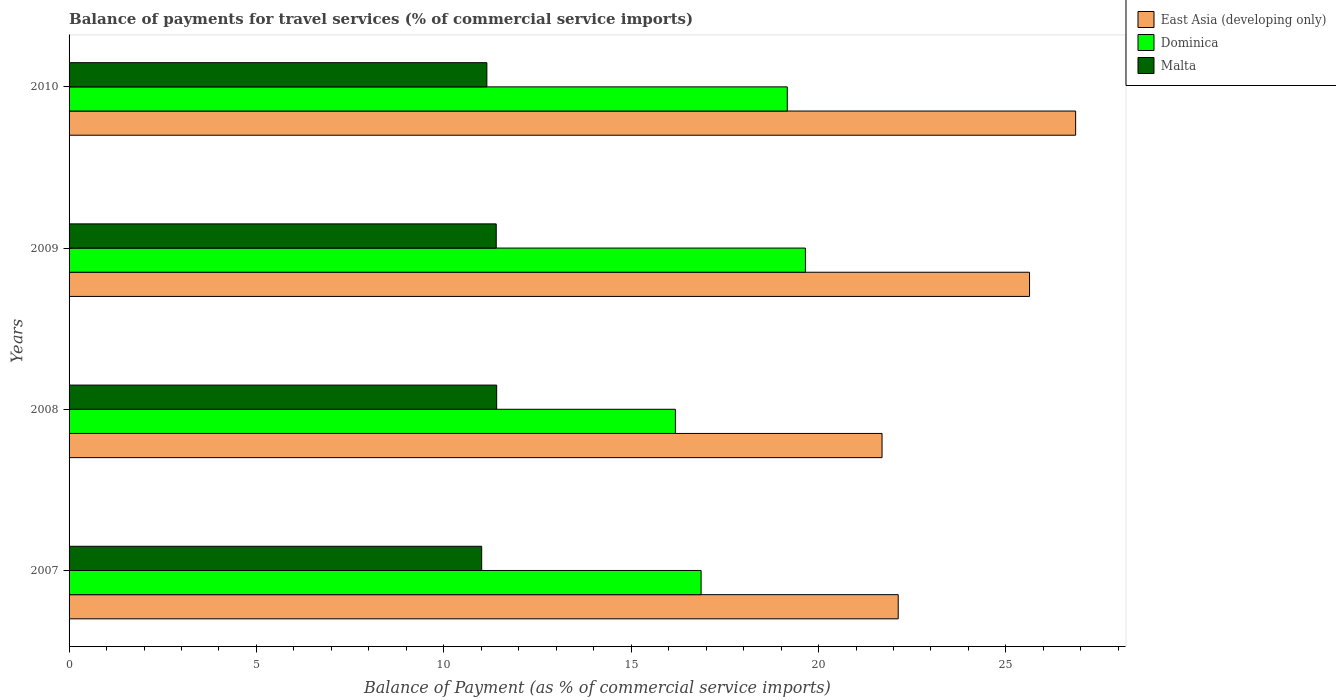How many different coloured bars are there?
Your answer should be very brief. 3. How many groups of bars are there?
Offer a very short reply. 4. Are the number of bars per tick equal to the number of legend labels?
Your answer should be very brief. Yes. Are the number of bars on each tick of the Y-axis equal?
Ensure brevity in your answer.  Yes. What is the balance of payments for travel services in Dominica in 2008?
Make the answer very short. 16.18. Across all years, what is the maximum balance of payments for travel services in Malta?
Your response must be concise. 11.41. Across all years, what is the minimum balance of payments for travel services in Dominica?
Your answer should be compact. 16.18. What is the total balance of payments for travel services in Dominica in the graph?
Provide a succinct answer. 71.86. What is the difference between the balance of payments for travel services in East Asia (developing only) in 2007 and that in 2010?
Provide a succinct answer. -4.73. What is the difference between the balance of payments for travel services in Malta in 2009 and the balance of payments for travel services in East Asia (developing only) in 2008?
Your answer should be compact. -10.3. What is the average balance of payments for travel services in Malta per year?
Your response must be concise. 11.24. In the year 2008, what is the difference between the balance of payments for travel services in East Asia (developing only) and balance of payments for travel services in Malta?
Your answer should be very brief. 10.28. What is the ratio of the balance of payments for travel services in Dominica in 2007 to that in 2010?
Offer a very short reply. 0.88. Is the difference between the balance of payments for travel services in East Asia (developing only) in 2007 and 2008 greater than the difference between the balance of payments for travel services in Malta in 2007 and 2008?
Offer a very short reply. Yes. What is the difference between the highest and the second highest balance of payments for travel services in Dominica?
Provide a short and direct response. 0.48. What is the difference between the highest and the lowest balance of payments for travel services in Malta?
Provide a succinct answer. 0.4. Is the sum of the balance of payments for travel services in Malta in 2007 and 2009 greater than the maximum balance of payments for travel services in Dominica across all years?
Make the answer very short. Yes. What does the 1st bar from the top in 2008 represents?
Your answer should be compact. Malta. What does the 2nd bar from the bottom in 2010 represents?
Provide a short and direct response. Dominica. Is it the case that in every year, the sum of the balance of payments for travel services in East Asia (developing only) and balance of payments for travel services in Malta is greater than the balance of payments for travel services in Dominica?
Keep it short and to the point. Yes. How many bars are there?
Make the answer very short. 12. How many years are there in the graph?
Provide a succinct answer. 4. Are the values on the major ticks of X-axis written in scientific E-notation?
Your response must be concise. No. Does the graph contain any zero values?
Offer a very short reply. No. Does the graph contain grids?
Your answer should be very brief. No. What is the title of the graph?
Keep it short and to the point. Balance of payments for travel services (% of commercial service imports). What is the label or title of the X-axis?
Your answer should be very brief. Balance of Payment (as % of commercial service imports). What is the Balance of Payment (as % of commercial service imports) in East Asia (developing only) in 2007?
Ensure brevity in your answer.  22.13. What is the Balance of Payment (as % of commercial service imports) of Dominica in 2007?
Your response must be concise. 16.87. What is the Balance of Payment (as % of commercial service imports) of Malta in 2007?
Your response must be concise. 11.01. What is the Balance of Payment (as % of commercial service imports) of East Asia (developing only) in 2008?
Keep it short and to the point. 21.69. What is the Balance of Payment (as % of commercial service imports) of Dominica in 2008?
Give a very brief answer. 16.18. What is the Balance of Payment (as % of commercial service imports) of Malta in 2008?
Give a very brief answer. 11.41. What is the Balance of Payment (as % of commercial service imports) in East Asia (developing only) in 2009?
Your response must be concise. 25.63. What is the Balance of Payment (as % of commercial service imports) in Dominica in 2009?
Keep it short and to the point. 19.65. What is the Balance of Payment (as % of commercial service imports) of Malta in 2009?
Give a very brief answer. 11.4. What is the Balance of Payment (as % of commercial service imports) of East Asia (developing only) in 2010?
Keep it short and to the point. 26.86. What is the Balance of Payment (as % of commercial service imports) of Dominica in 2010?
Ensure brevity in your answer.  19.17. What is the Balance of Payment (as % of commercial service imports) of Malta in 2010?
Provide a succinct answer. 11.15. Across all years, what is the maximum Balance of Payment (as % of commercial service imports) in East Asia (developing only)?
Your response must be concise. 26.86. Across all years, what is the maximum Balance of Payment (as % of commercial service imports) in Dominica?
Keep it short and to the point. 19.65. Across all years, what is the maximum Balance of Payment (as % of commercial service imports) of Malta?
Give a very brief answer. 11.41. Across all years, what is the minimum Balance of Payment (as % of commercial service imports) in East Asia (developing only)?
Provide a succinct answer. 21.69. Across all years, what is the minimum Balance of Payment (as % of commercial service imports) of Dominica?
Keep it short and to the point. 16.18. Across all years, what is the minimum Balance of Payment (as % of commercial service imports) of Malta?
Your response must be concise. 11.01. What is the total Balance of Payment (as % of commercial service imports) of East Asia (developing only) in the graph?
Your answer should be compact. 96.31. What is the total Balance of Payment (as % of commercial service imports) of Dominica in the graph?
Provide a succinct answer. 71.86. What is the total Balance of Payment (as % of commercial service imports) in Malta in the graph?
Your response must be concise. 44.97. What is the difference between the Balance of Payment (as % of commercial service imports) of East Asia (developing only) in 2007 and that in 2008?
Provide a succinct answer. 0.43. What is the difference between the Balance of Payment (as % of commercial service imports) of Dominica in 2007 and that in 2008?
Your response must be concise. 0.69. What is the difference between the Balance of Payment (as % of commercial service imports) of Malta in 2007 and that in 2008?
Your response must be concise. -0.4. What is the difference between the Balance of Payment (as % of commercial service imports) in East Asia (developing only) in 2007 and that in 2009?
Give a very brief answer. -3.5. What is the difference between the Balance of Payment (as % of commercial service imports) in Dominica in 2007 and that in 2009?
Make the answer very short. -2.78. What is the difference between the Balance of Payment (as % of commercial service imports) in Malta in 2007 and that in 2009?
Ensure brevity in your answer.  -0.39. What is the difference between the Balance of Payment (as % of commercial service imports) in East Asia (developing only) in 2007 and that in 2010?
Give a very brief answer. -4.73. What is the difference between the Balance of Payment (as % of commercial service imports) in Dominica in 2007 and that in 2010?
Keep it short and to the point. -2.3. What is the difference between the Balance of Payment (as % of commercial service imports) in Malta in 2007 and that in 2010?
Your answer should be very brief. -0.14. What is the difference between the Balance of Payment (as % of commercial service imports) of East Asia (developing only) in 2008 and that in 2009?
Your response must be concise. -3.94. What is the difference between the Balance of Payment (as % of commercial service imports) of Dominica in 2008 and that in 2009?
Offer a terse response. -3.47. What is the difference between the Balance of Payment (as % of commercial service imports) of Malta in 2008 and that in 2009?
Provide a short and direct response. 0.01. What is the difference between the Balance of Payment (as % of commercial service imports) in East Asia (developing only) in 2008 and that in 2010?
Make the answer very short. -5.17. What is the difference between the Balance of Payment (as % of commercial service imports) in Dominica in 2008 and that in 2010?
Your answer should be very brief. -2.99. What is the difference between the Balance of Payment (as % of commercial service imports) in Malta in 2008 and that in 2010?
Ensure brevity in your answer.  0.26. What is the difference between the Balance of Payment (as % of commercial service imports) of East Asia (developing only) in 2009 and that in 2010?
Your answer should be compact. -1.23. What is the difference between the Balance of Payment (as % of commercial service imports) of Dominica in 2009 and that in 2010?
Keep it short and to the point. 0.48. What is the difference between the Balance of Payment (as % of commercial service imports) of Malta in 2009 and that in 2010?
Offer a terse response. 0.25. What is the difference between the Balance of Payment (as % of commercial service imports) of East Asia (developing only) in 2007 and the Balance of Payment (as % of commercial service imports) of Dominica in 2008?
Provide a short and direct response. 5.95. What is the difference between the Balance of Payment (as % of commercial service imports) of East Asia (developing only) in 2007 and the Balance of Payment (as % of commercial service imports) of Malta in 2008?
Ensure brevity in your answer.  10.71. What is the difference between the Balance of Payment (as % of commercial service imports) in Dominica in 2007 and the Balance of Payment (as % of commercial service imports) in Malta in 2008?
Provide a short and direct response. 5.46. What is the difference between the Balance of Payment (as % of commercial service imports) of East Asia (developing only) in 2007 and the Balance of Payment (as % of commercial service imports) of Dominica in 2009?
Provide a succinct answer. 2.48. What is the difference between the Balance of Payment (as % of commercial service imports) in East Asia (developing only) in 2007 and the Balance of Payment (as % of commercial service imports) in Malta in 2009?
Your answer should be very brief. 10.73. What is the difference between the Balance of Payment (as % of commercial service imports) in Dominica in 2007 and the Balance of Payment (as % of commercial service imports) in Malta in 2009?
Your answer should be very brief. 5.47. What is the difference between the Balance of Payment (as % of commercial service imports) of East Asia (developing only) in 2007 and the Balance of Payment (as % of commercial service imports) of Dominica in 2010?
Make the answer very short. 2.96. What is the difference between the Balance of Payment (as % of commercial service imports) of East Asia (developing only) in 2007 and the Balance of Payment (as % of commercial service imports) of Malta in 2010?
Provide a succinct answer. 10.98. What is the difference between the Balance of Payment (as % of commercial service imports) in Dominica in 2007 and the Balance of Payment (as % of commercial service imports) in Malta in 2010?
Provide a succinct answer. 5.72. What is the difference between the Balance of Payment (as % of commercial service imports) in East Asia (developing only) in 2008 and the Balance of Payment (as % of commercial service imports) in Dominica in 2009?
Your response must be concise. 2.04. What is the difference between the Balance of Payment (as % of commercial service imports) of East Asia (developing only) in 2008 and the Balance of Payment (as % of commercial service imports) of Malta in 2009?
Offer a terse response. 10.3. What is the difference between the Balance of Payment (as % of commercial service imports) of Dominica in 2008 and the Balance of Payment (as % of commercial service imports) of Malta in 2009?
Your response must be concise. 4.78. What is the difference between the Balance of Payment (as % of commercial service imports) in East Asia (developing only) in 2008 and the Balance of Payment (as % of commercial service imports) in Dominica in 2010?
Make the answer very short. 2.53. What is the difference between the Balance of Payment (as % of commercial service imports) in East Asia (developing only) in 2008 and the Balance of Payment (as % of commercial service imports) in Malta in 2010?
Your answer should be very brief. 10.55. What is the difference between the Balance of Payment (as % of commercial service imports) of Dominica in 2008 and the Balance of Payment (as % of commercial service imports) of Malta in 2010?
Provide a short and direct response. 5.03. What is the difference between the Balance of Payment (as % of commercial service imports) in East Asia (developing only) in 2009 and the Balance of Payment (as % of commercial service imports) in Dominica in 2010?
Make the answer very short. 6.46. What is the difference between the Balance of Payment (as % of commercial service imports) of East Asia (developing only) in 2009 and the Balance of Payment (as % of commercial service imports) of Malta in 2010?
Your answer should be compact. 14.48. What is the difference between the Balance of Payment (as % of commercial service imports) in Dominica in 2009 and the Balance of Payment (as % of commercial service imports) in Malta in 2010?
Provide a succinct answer. 8.5. What is the average Balance of Payment (as % of commercial service imports) of East Asia (developing only) per year?
Provide a short and direct response. 24.08. What is the average Balance of Payment (as % of commercial service imports) of Dominica per year?
Provide a short and direct response. 17.97. What is the average Balance of Payment (as % of commercial service imports) in Malta per year?
Make the answer very short. 11.24. In the year 2007, what is the difference between the Balance of Payment (as % of commercial service imports) of East Asia (developing only) and Balance of Payment (as % of commercial service imports) of Dominica?
Make the answer very short. 5.26. In the year 2007, what is the difference between the Balance of Payment (as % of commercial service imports) in East Asia (developing only) and Balance of Payment (as % of commercial service imports) in Malta?
Your answer should be very brief. 11.12. In the year 2007, what is the difference between the Balance of Payment (as % of commercial service imports) of Dominica and Balance of Payment (as % of commercial service imports) of Malta?
Offer a terse response. 5.86. In the year 2008, what is the difference between the Balance of Payment (as % of commercial service imports) in East Asia (developing only) and Balance of Payment (as % of commercial service imports) in Dominica?
Ensure brevity in your answer.  5.51. In the year 2008, what is the difference between the Balance of Payment (as % of commercial service imports) of East Asia (developing only) and Balance of Payment (as % of commercial service imports) of Malta?
Make the answer very short. 10.28. In the year 2008, what is the difference between the Balance of Payment (as % of commercial service imports) of Dominica and Balance of Payment (as % of commercial service imports) of Malta?
Your response must be concise. 4.77. In the year 2009, what is the difference between the Balance of Payment (as % of commercial service imports) of East Asia (developing only) and Balance of Payment (as % of commercial service imports) of Dominica?
Your response must be concise. 5.98. In the year 2009, what is the difference between the Balance of Payment (as % of commercial service imports) of East Asia (developing only) and Balance of Payment (as % of commercial service imports) of Malta?
Provide a succinct answer. 14.23. In the year 2009, what is the difference between the Balance of Payment (as % of commercial service imports) in Dominica and Balance of Payment (as % of commercial service imports) in Malta?
Your answer should be compact. 8.25. In the year 2010, what is the difference between the Balance of Payment (as % of commercial service imports) in East Asia (developing only) and Balance of Payment (as % of commercial service imports) in Dominica?
Ensure brevity in your answer.  7.7. In the year 2010, what is the difference between the Balance of Payment (as % of commercial service imports) in East Asia (developing only) and Balance of Payment (as % of commercial service imports) in Malta?
Your answer should be compact. 15.71. In the year 2010, what is the difference between the Balance of Payment (as % of commercial service imports) in Dominica and Balance of Payment (as % of commercial service imports) in Malta?
Your answer should be very brief. 8.02. What is the ratio of the Balance of Payment (as % of commercial service imports) of East Asia (developing only) in 2007 to that in 2008?
Offer a terse response. 1.02. What is the ratio of the Balance of Payment (as % of commercial service imports) in Dominica in 2007 to that in 2008?
Offer a terse response. 1.04. What is the ratio of the Balance of Payment (as % of commercial service imports) of Malta in 2007 to that in 2008?
Offer a very short reply. 0.96. What is the ratio of the Balance of Payment (as % of commercial service imports) in East Asia (developing only) in 2007 to that in 2009?
Your answer should be compact. 0.86. What is the ratio of the Balance of Payment (as % of commercial service imports) in Dominica in 2007 to that in 2009?
Provide a short and direct response. 0.86. What is the ratio of the Balance of Payment (as % of commercial service imports) in Malta in 2007 to that in 2009?
Give a very brief answer. 0.97. What is the ratio of the Balance of Payment (as % of commercial service imports) in East Asia (developing only) in 2007 to that in 2010?
Offer a very short reply. 0.82. What is the ratio of the Balance of Payment (as % of commercial service imports) of Dominica in 2007 to that in 2010?
Provide a short and direct response. 0.88. What is the ratio of the Balance of Payment (as % of commercial service imports) in Malta in 2007 to that in 2010?
Ensure brevity in your answer.  0.99. What is the ratio of the Balance of Payment (as % of commercial service imports) in East Asia (developing only) in 2008 to that in 2009?
Your response must be concise. 0.85. What is the ratio of the Balance of Payment (as % of commercial service imports) in Dominica in 2008 to that in 2009?
Ensure brevity in your answer.  0.82. What is the ratio of the Balance of Payment (as % of commercial service imports) of Malta in 2008 to that in 2009?
Your answer should be very brief. 1. What is the ratio of the Balance of Payment (as % of commercial service imports) of East Asia (developing only) in 2008 to that in 2010?
Ensure brevity in your answer.  0.81. What is the ratio of the Balance of Payment (as % of commercial service imports) in Dominica in 2008 to that in 2010?
Provide a succinct answer. 0.84. What is the ratio of the Balance of Payment (as % of commercial service imports) in Malta in 2008 to that in 2010?
Ensure brevity in your answer.  1.02. What is the ratio of the Balance of Payment (as % of commercial service imports) in East Asia (developing only) in 2009 to that in 2010?
Make the answer very short. 0.95. What is the ratio of the Balance of Payment (as % of commercial service imports) of Dominica in 2009 to that in 2010?
Ensure brevity in your answer.  1.03. What is the ratio of the Balance of Payment (as % of commercial service imports) of Malta in 2009 to that in 2010?
Your answer should be compact. 1.02. What is the difference between the highest and the second highest Balance of Payment (as % of commercial service imports) in East Asia (developing only)?
Ensure brevity in your answer.  1.23. What is the difference between the highest and the second highest Balance of Payment (as % of commercial service imports) of Dominica?
Offer a terse response. 0.48. What is the difference between the highest and the second highest Balance of Payment (as % of commercial service imports) of Malta?
Give a very brief answer. 0.01. What is the difference between the highest and the lowest Balance of Payment (as % of commercial service imports) of East Asia (developing only)?
Offer a terse response. 5.17. What is the difference between the highest and the lowest Balance of Payment (as % of commercial service imports) of Dominica?
Your answer should be very brief. 3.47. What is the difference between the highest and the lowest Balance of Payment (as % of commercial service imports) of Malta?
Provide a succinct answer. 0.4. 